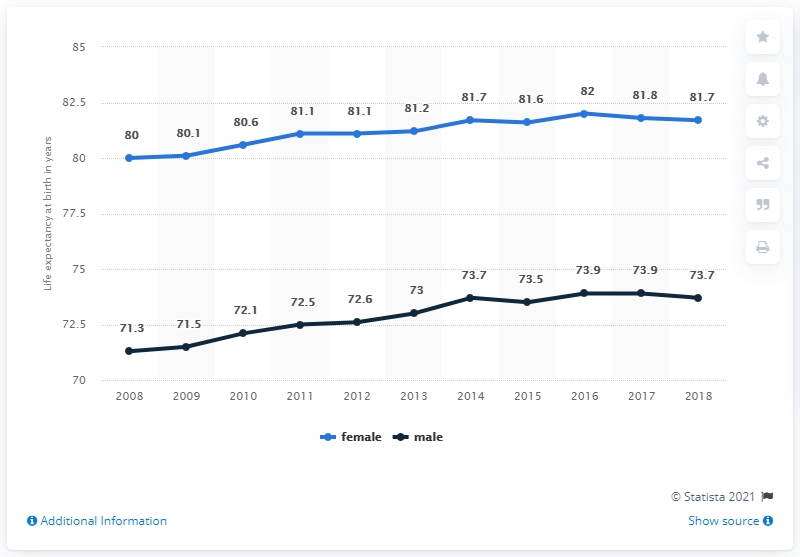Indicate a few pertinent items in this graphic. In the provided data, the first year is 2008. The average life expectancy in 2017 and 2018 (combined) was 77.775 years. 